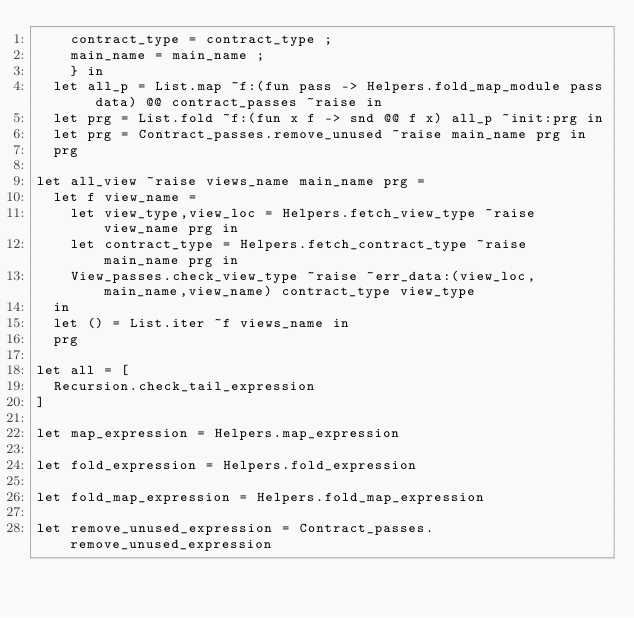Convert code to text. <code><loc_0><loc_0><loc_500><loc_500><_OCaml_>    contract_type = contract_type ;
    main_name = main_name ;
    } in
  let all_p = List.map ~f:(fun pass -> Helpers.fold_map_module pass data) @@ contract_passes ~raise in
  let prg = List.fold ~f:(fun x f -> snd @@ f x) all_p ~init:prg in
  let prg = Contract_passes.remove_unused ~raise main_name prg in
  prg

let all_view ~raise views_name main_name prg =
  let f view_name =
    let view_type,view_loc = Helpers.fetch_view_type ~raise view_name prg in
    let contract_type = Helpers.fetch_contract_type ~raise main_name prg in
    View_passes.check_view_type ~raise ~err_data:(view_loc,main_name,view_name) contract_type view_type
  in
  let () = List.iter ~f views_name in
  prg

let all = [
  Recursion.check_tail_expression
]

let map_expression = Helpers.map_expression

let fold_expression = Helpers.fold_expression

let fold_map_expression = Helpers.fold_map_expression

let remove_unused_expression = Contract_passes.remove_unused_expression
</code> 